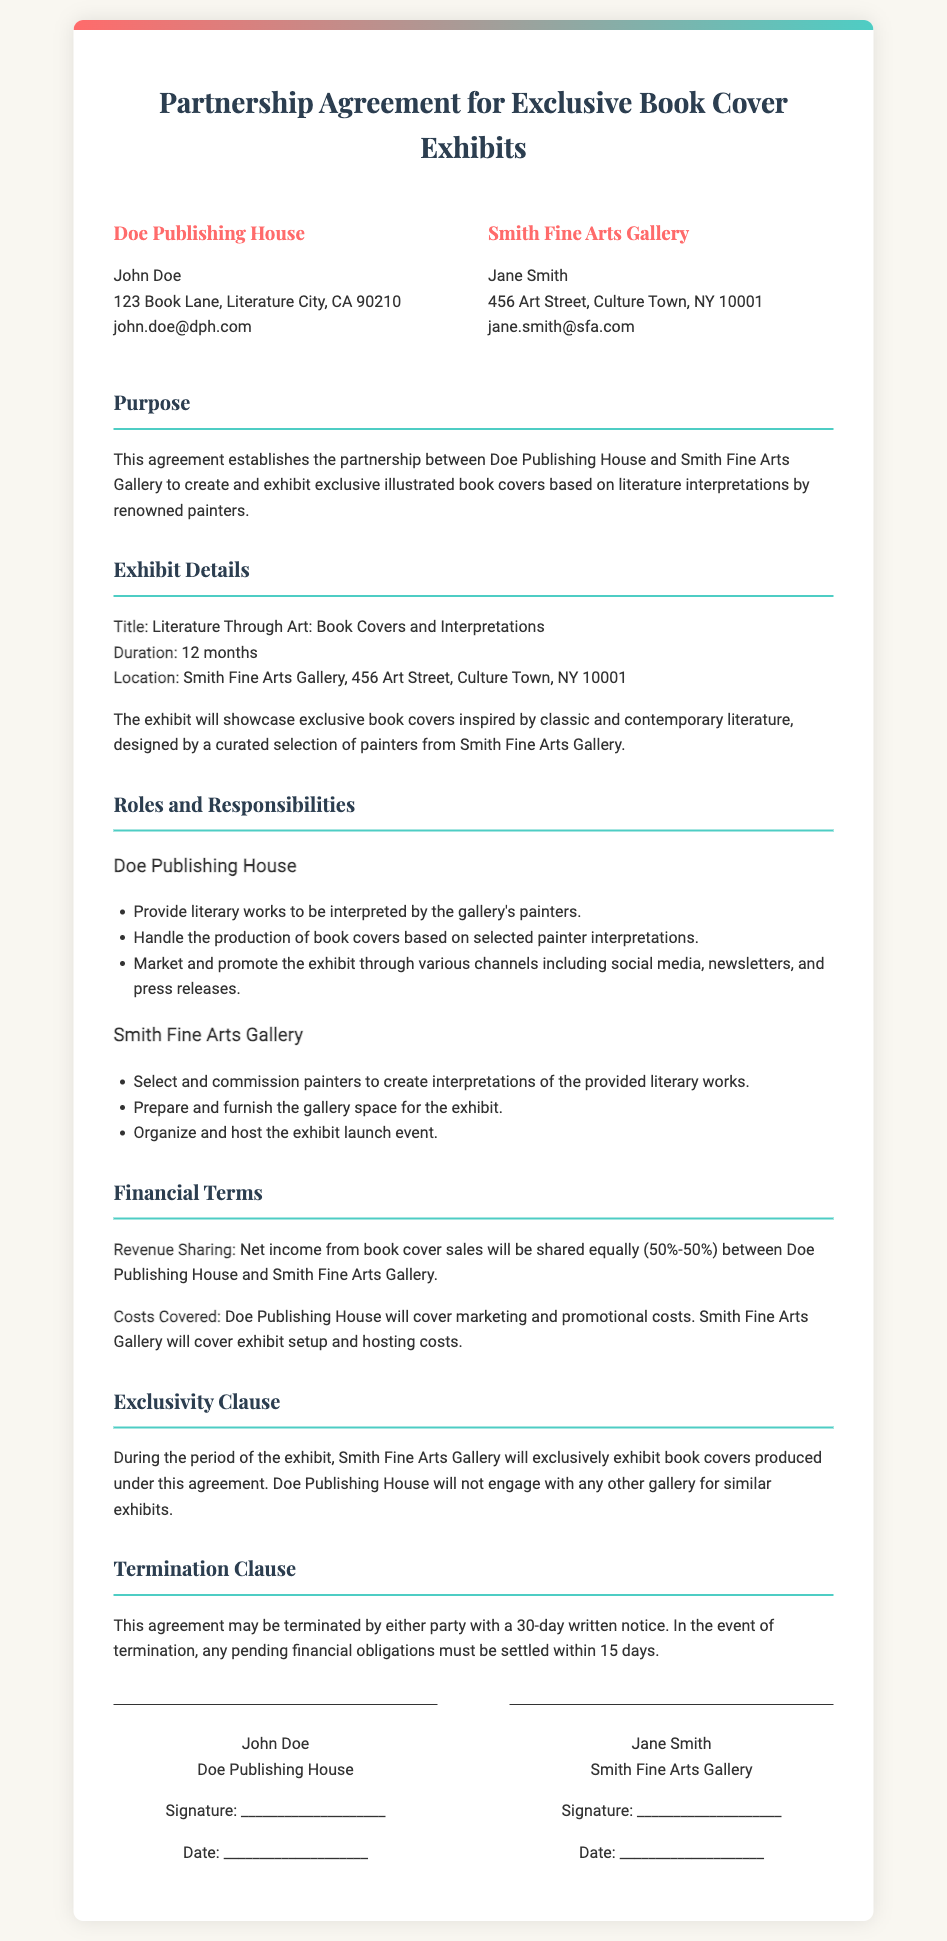what is the title of the exhibit? The title of the exhibit is explicitly mentioned in the document as "Literature Through Art: Book Covers and Interpretations."
Answer: Literature Through Art: Book Covers and Interpretations who represents Doe Publishing House? The document lists John Doe as the representative of Doe Publishing House.
Answer: John Doe what is the share of net income from book cover sales for each party? The agreement states that the net income from book cover sales will be shared equally with both parties receiving 50%.
Answer: 50%-50% how long is the duration of the exhibit? The duration of the exhibit is specified in the document as 12 months.
Answer: 12 months what costs will Doe Publishing House cover? The document specifies that Doe Publishing House will cover marketing and promotional costs.
Answer: marketing and promotional costs what is the termination notice period mentioned in the agreement? The termination clause states that either party may terminate with a 30-day written notice.
Answer: 30-day where is the location of the exhibit? The location of the exhibit is stated as Smith Fine Arts Gallery, 456 Art Street, Culture Town, NY 10001.
Answer: Smith Fine Arts Gallery, 456 Art Street, Culture Town, NY 10001 who is responsible for preparing the gallery space for the exhibit? Smith Fine Arts Gallery is tasked with preparing and furnishing the gallery space for the exhibit as mentioned in the responsibilities section.
Answer: Smith Fine Arts Gallery 